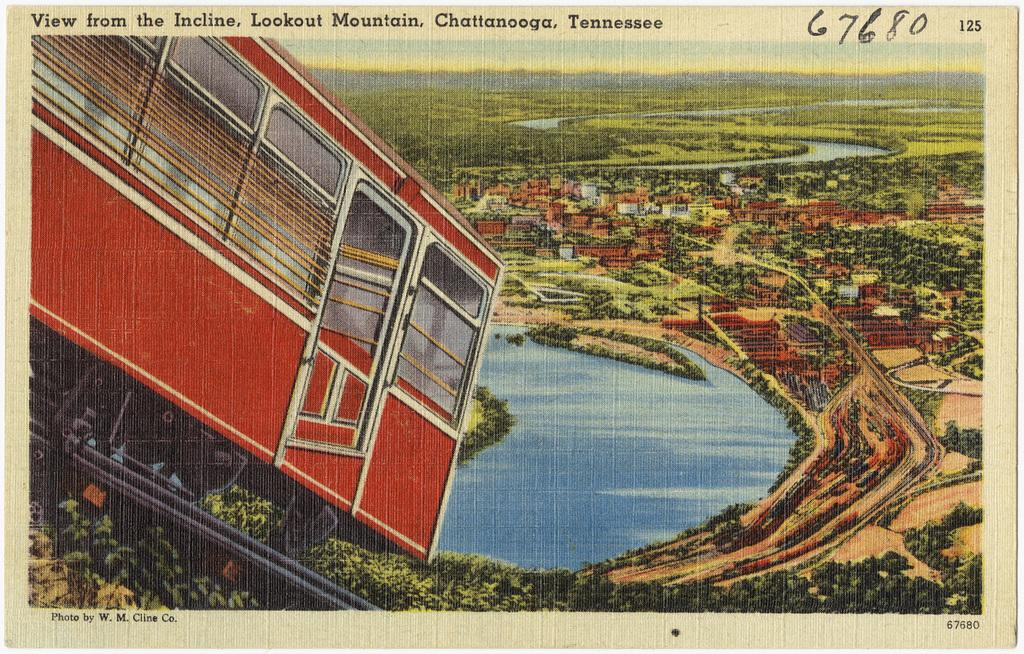<image>
Present a compact description of the photo's key features. A drawing of a cable car on a hillside titled View from the Incline, Look at Mountain Chattanooga, Tennessee. 